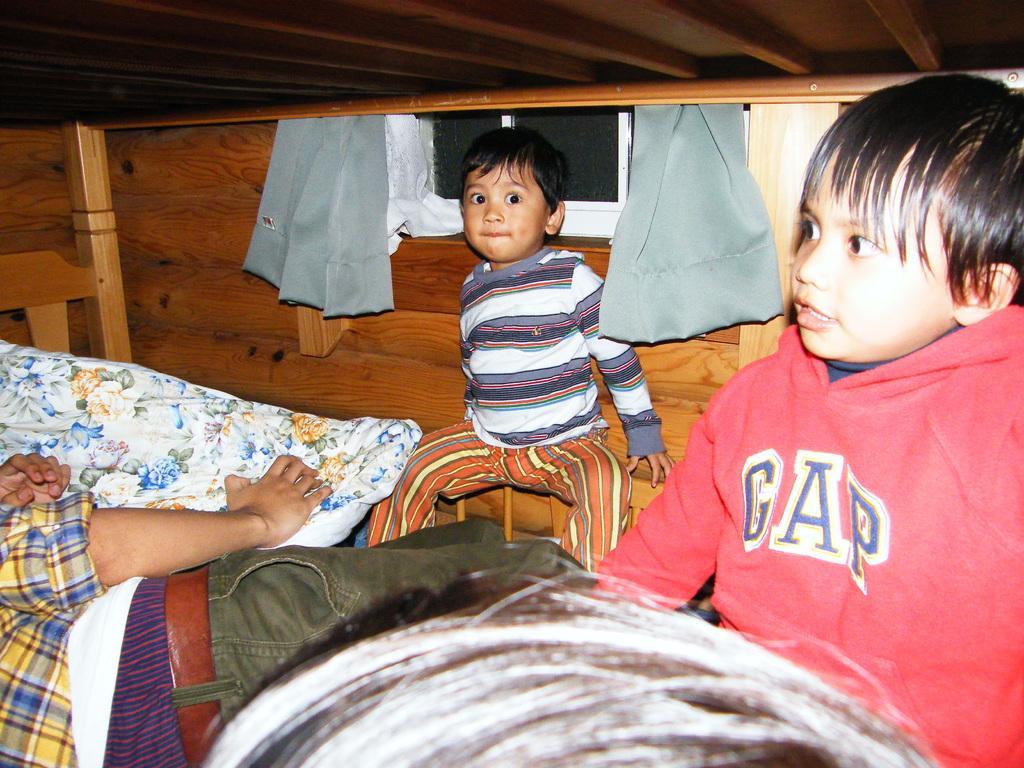Please provide a concise description of this image. In this picture I can see a person laying on the bed and holding a pillow , there are two boys sitting , and in the background there is a wooden wall, curtains and a window. 